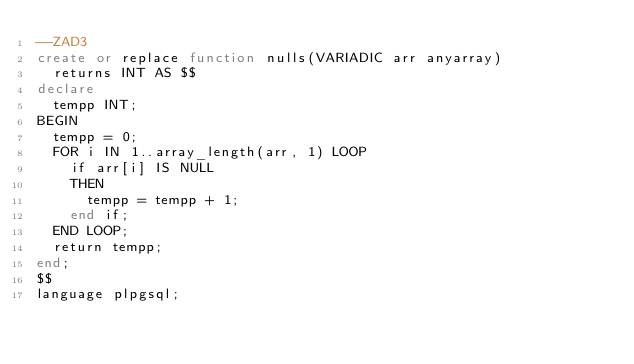Convert code to text. <code><loc_0><loc_0><loc_500><loc_500><_SQL_>--ZAD3
create or replace function nulls(VARIADIC arr anyarray)
  returns INT AS $$
declare
  tempp INT;
BEGIN
  tempp = 0;
  FOR i IN 1..array_length(arr, 1) LOOP
    if arr[i] IS NULL
    THEN
      tempp = tempp + 1;
    end if;
  END LOOP;
  return tempp;
end;
$$
language plpgsql;</code> 